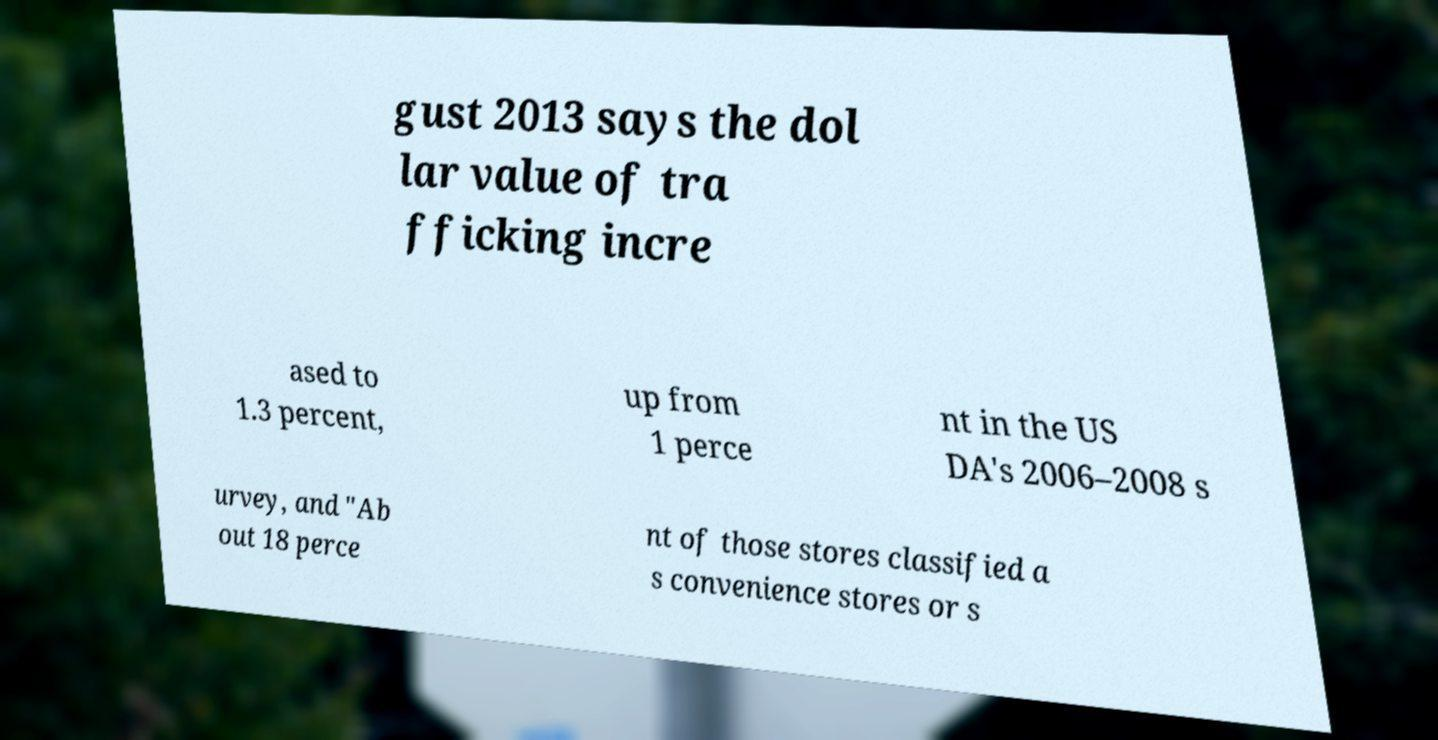Could you assist in decoding the text presented in this image and type it out clearly? gust 2013 says the dol lar value of tra fficking incre ased to 1.3 percent, up from 1 perce nt in the US DA's 2006–2008 s urvey, and "Ab out 18 perce nt of those stores classified a s convenience stores or s 